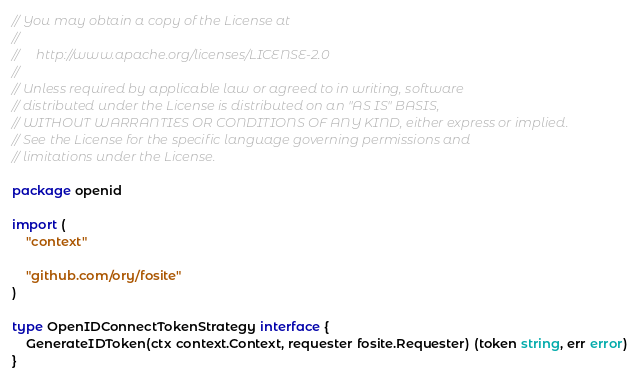Convert code to text. <code><loc_0><loc_0><loc_500><loc_500><_Go_>// You may obtain a copy of the License at
//
//     http://www.apache.org/licenses/LICENSE-2.0
//
// Unless required by applicable law or agreed to in writing, software
// distributed under the License is distributed on an "AS IS" BASIS,
// WITHOUT WARRANTIES OR CONDITIONS OF ANY KIND, either express or implied.
// See the License for the specific language governing permissions and
// limitations under the License.

package openid

import (
	"context"

	"github.com/ory/fosite"
)

type OpenIDConnectTokenStrategy interface {
	GenerateIDToken(ctx context.Context, requester fosite.Requester) (token string, err error)
}
</code> 